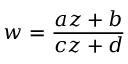<formula> <loc_0><loc_0><loc_500><loc_500>w = { \frac { a z + b } { c z + d } }</formula> 